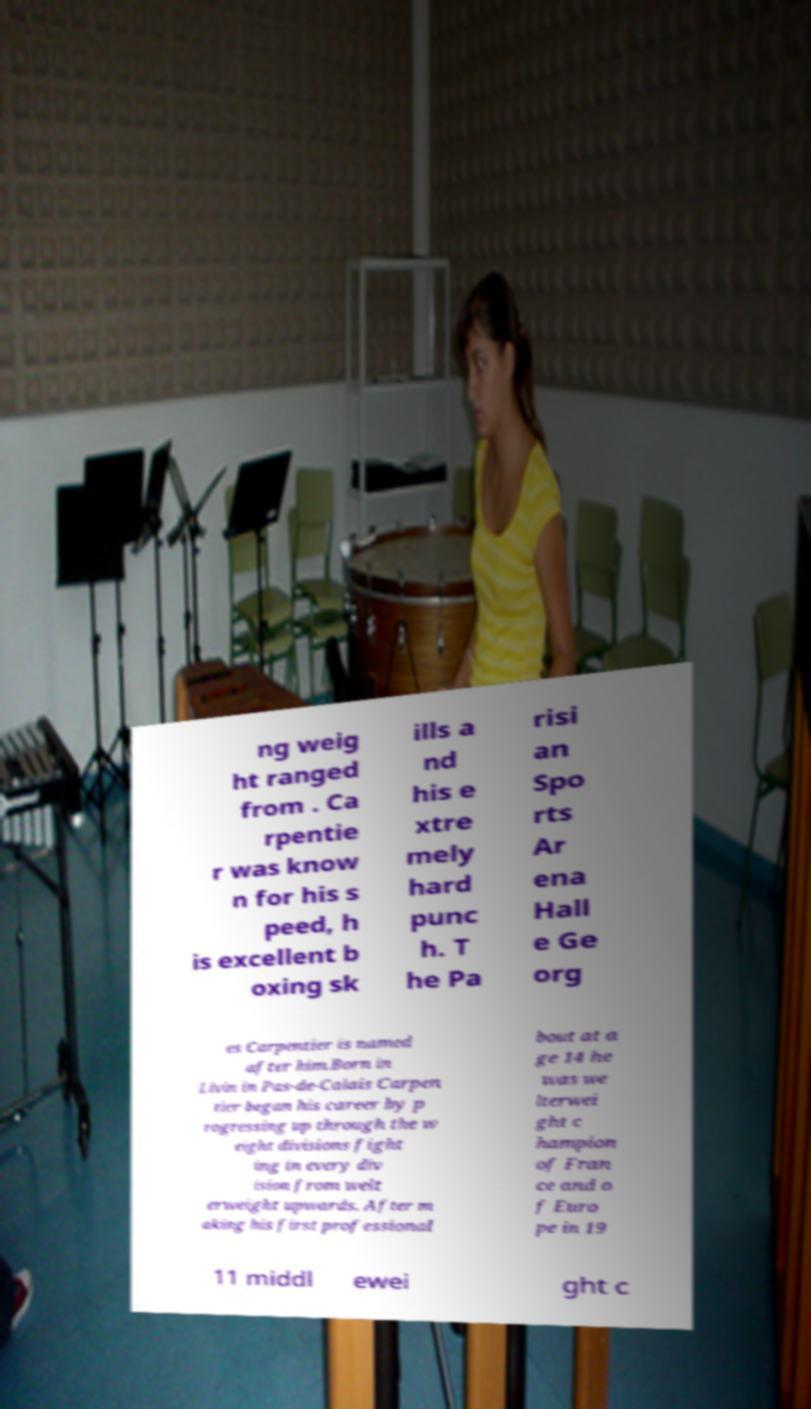Please read and relay the text visible in this image. What does it say? ng weig ht ranged from . Ca rpentie r was know n for his s peed, h is excellent b oxing sk ills a nd his e xtre mely hard punc h. T he Pa risi an Spo rts Ar ena Hall e Ge org es Carpentier is named after him.Born in Livin in Pas-de-Calais Carpen tier began his career by p rogressing up through the w eight divisions fight ing in every div ision from welt erweight upwards. After m aking his first professional bout at a ge 14 he was we lterwei ght c hampion of Fran ce and o f Euro pe in 19 11 middl ewei ght c 